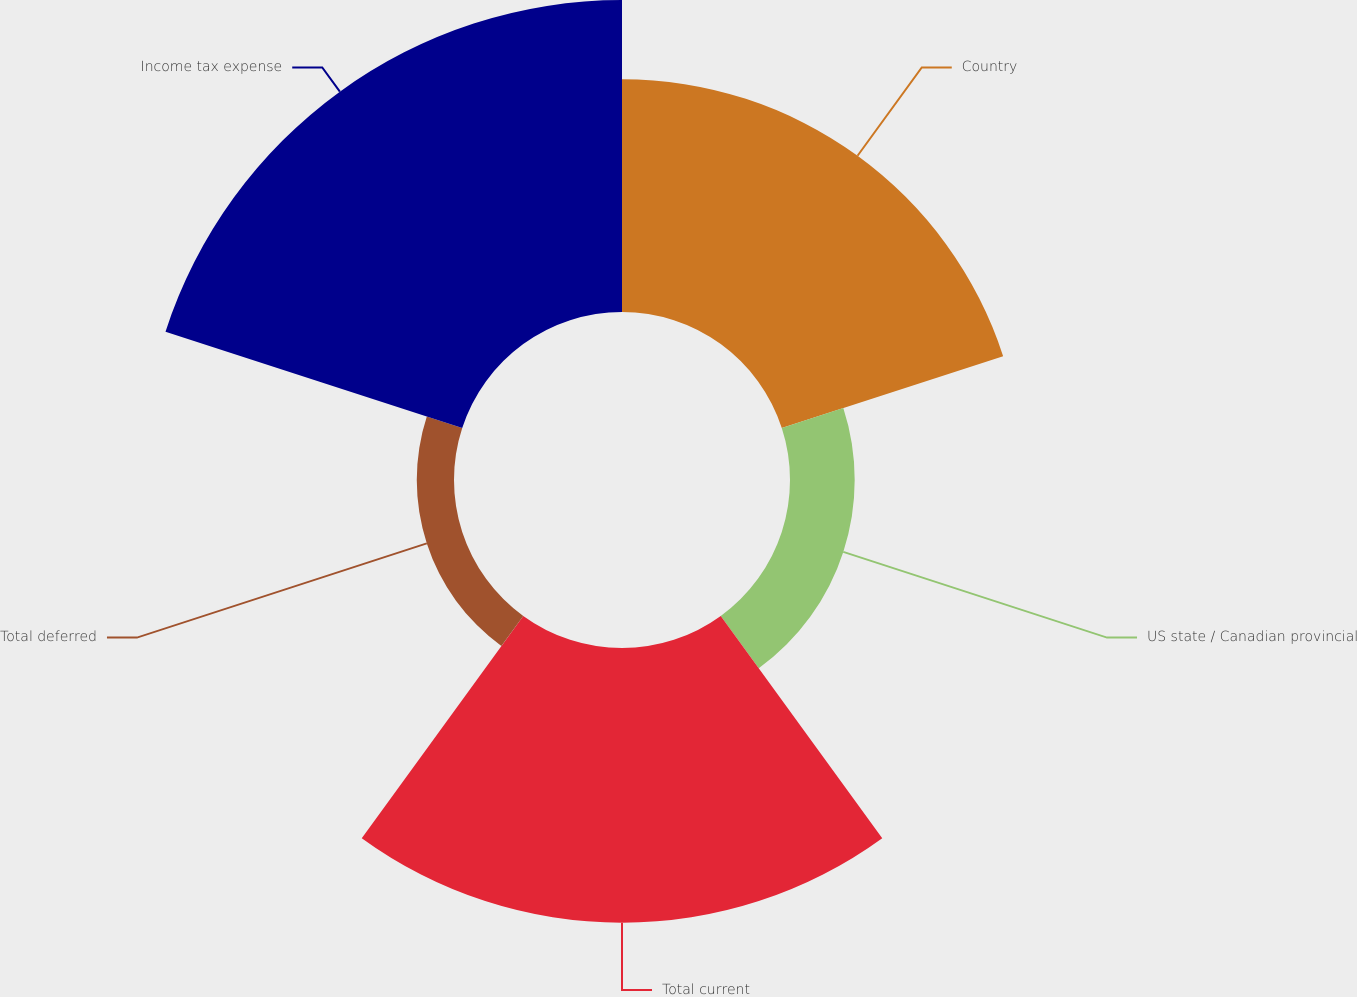Convert chart. <chart><loc_0><loc_0><loc_500><loc_500><pie_chart><fcel>Country<fcel>US state / Canadian provincial<fcel>Total current<fcel>Total deferred<fcel>Income tax expense<nl><fcel>25.26%<fcel>7.02%<fcel>29.82%<fcel>4.04%<fcel>33.86%<nl></chart> 